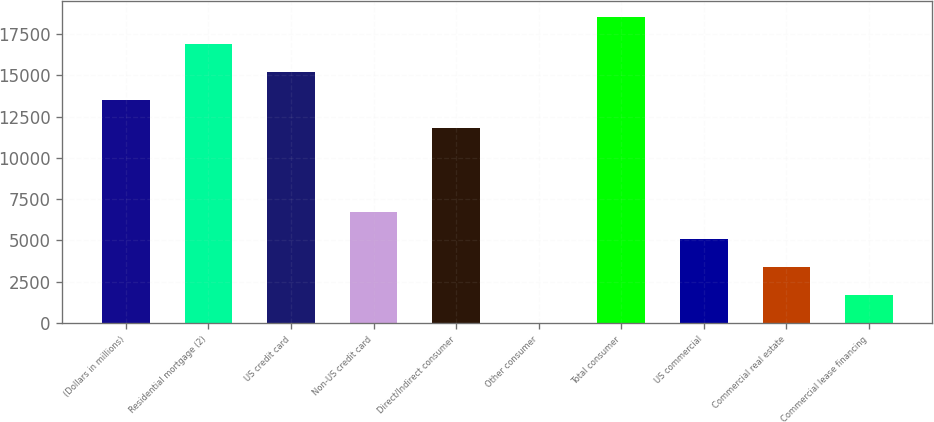<chart> <loc_0><loc_0><loc_500><loc_500><bar_chart><fcel>(Dollars in millions)<fcel>Residential mortgage (2)<fcel>US credit card<fcel>Non-US credit card<fcel>Direct/Indirect consumer<fcel>Other consumer<fcel>Total consumer<fcel>US commercial<fcel>Commercial real estate<fcel>Commercial lease financing<nl><fcel>13488.6<fcel>16860<fcel>15174.3<fcel>6745.8<fcel>11802.9<fcel>3<fcel>18545.7<fcel>5060.1<fcel>3374.4<fcel>1688.7<nl></chart> 